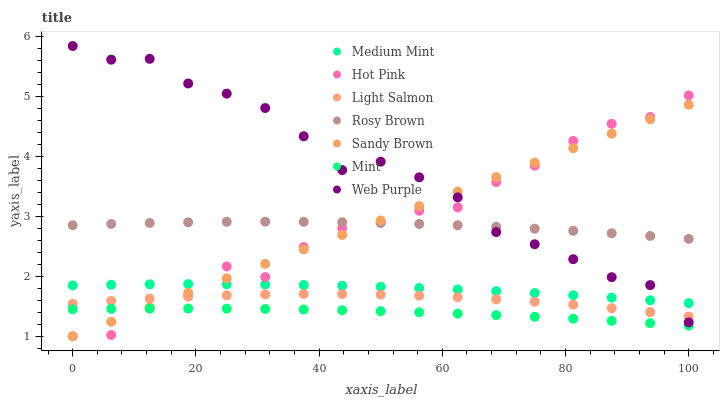Does Mint have the minimum area under the curve?
Answer yes or no. Yes. Does Web Purple have the maximum area under the curve?
Answer yes or no. Yes. Does Light Salmon have the minimum area under the curve?
Answer yes or no. No. Does Light Salmon have the maximum area under the curve?
Answer yes or no. No. Is Sandy Brown the smoothest?
Answer yes or no. Yes. Is Hot Pink the roughest?
Answer yes or no. Yes. Is Light Salmon the smoothest?
Answer yes or no. No. Is Light Salmon the roughest?
Answer yes or no. No. Does Sandy Brown have the lowest value?
Answer yes or no. Yes. Does Light Salmon have the lowest value?
Answer yes or no. No. Does Web Purple have the highest value?
Answer yes or no. Yes. Does Light Salmon have the highest value?
Answer yes or no. No. Is Light Salmon less than Medium Mint?
Answer yes or no. Yes. Is Rosy Brown greater than Light Salmon?
Answer yes or no. Yes. Does Sandy Brown intersect Mint?
Answer yes or no. Yes. Is Sandy Brown less than Mint?
Answer yes or no. No. Is Sandy Brown greater than Mint?
Answer yes or no. No. Does Light Salmon intersect Medium Mint?
Answer yes or no. No. 